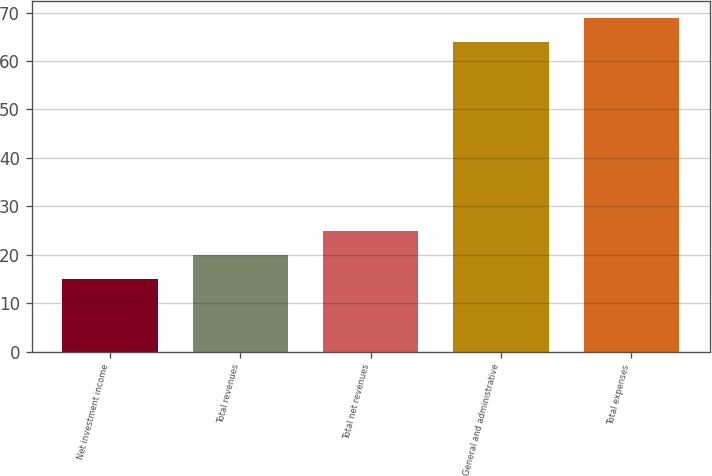Convert chart. <chart><loc_0><loc_0><loc_500><loc_500><bar_chart><fcel>Net investment income<fcel>Total revenues<fcel>Total net revenues<fcel>General and administrative<fcel>Total expenses<nl><fcel>15<fcel>19.9<fcel>24.8<fcel>64<fcel>68.9<nl></chart> 